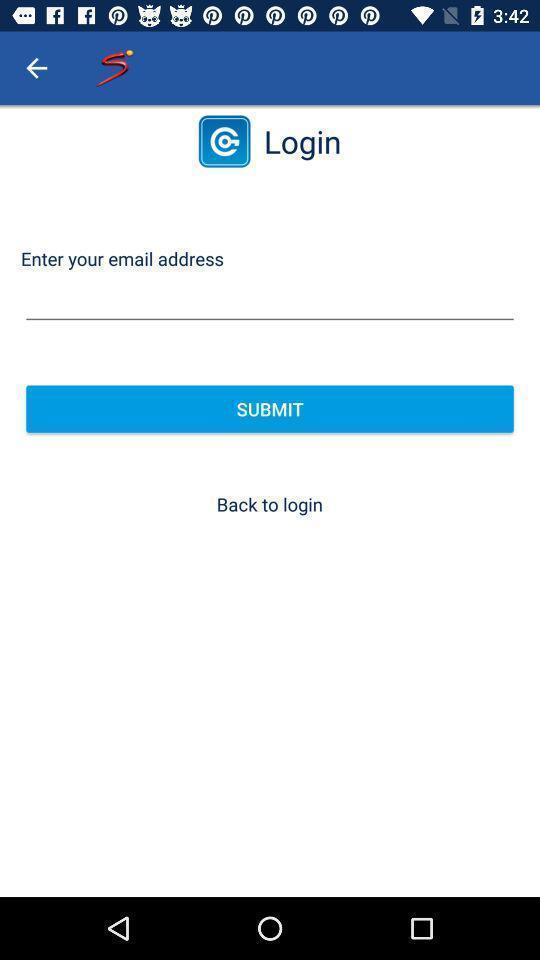Describe the visual elements of this screenshot. Page for entering email address to login. 